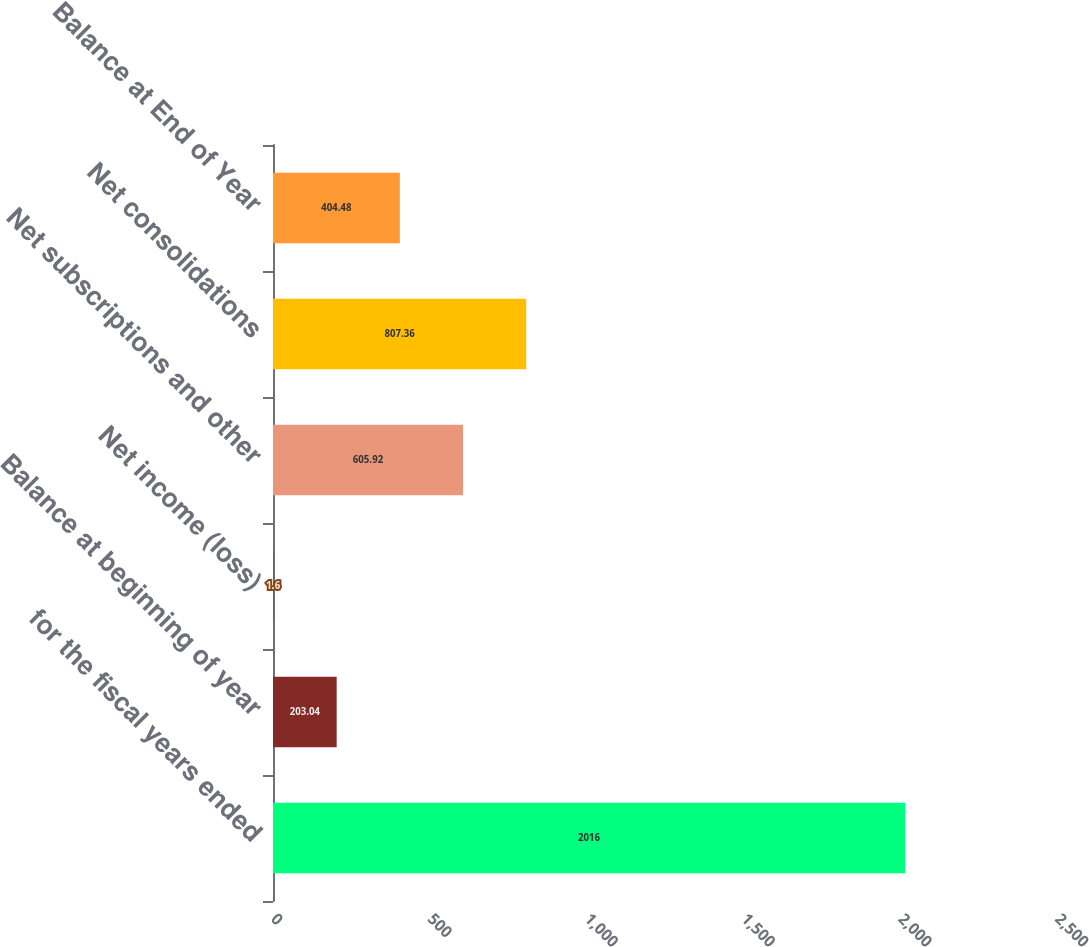<chart> <loc_0><loc_0><loc_500><loc_500><bar_chart><fcel>for the fiscal years ended<fcel>Balance at beginning of year<fcel>Net income (loss)<fcel>Net subscriptions and other<fcel>Net consolidations<fcel>Balance at End of Year<nl><fcel>2016<fcel>203.04<fcel>1.6<fcel>605.92<fcel>807.36<fcel>404.48<nl></chart> 